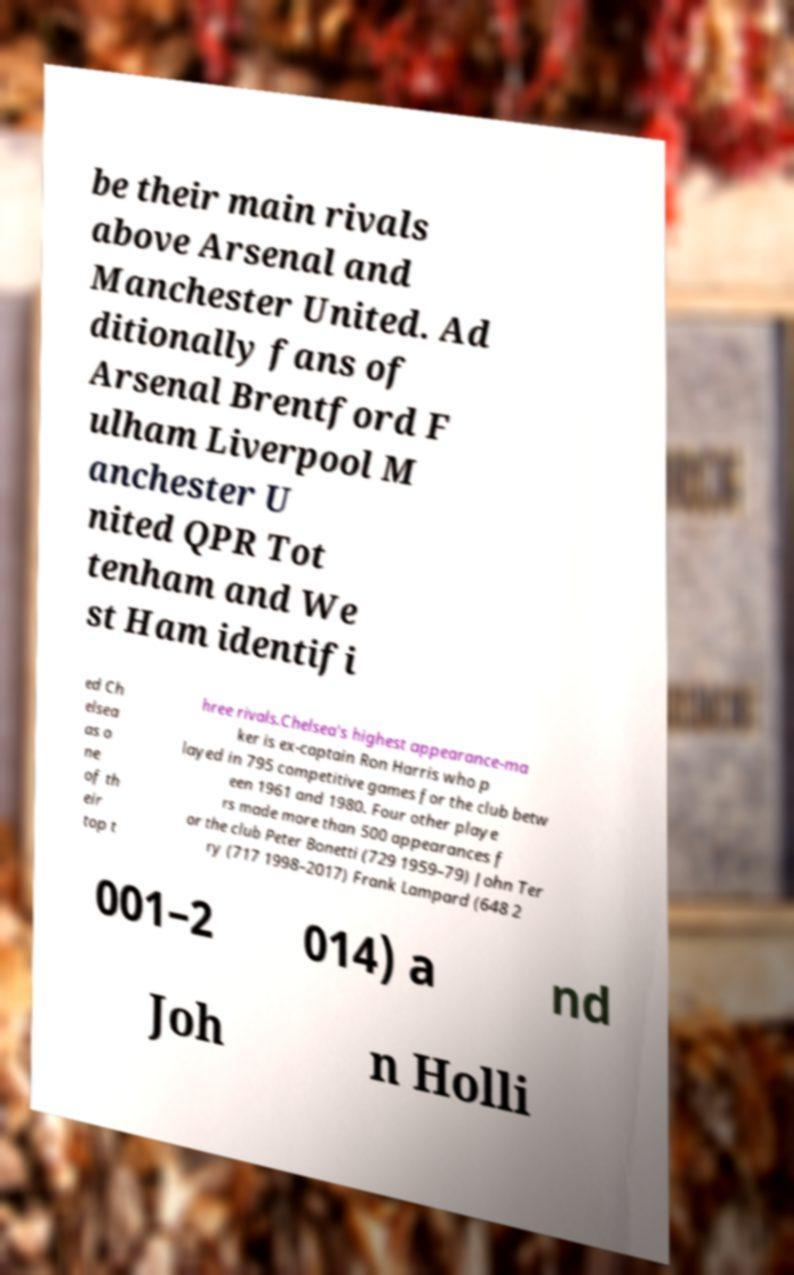Can you read and provide the text displayed in the image?This photo seems to have some interesting text. Can you extract and type it out for me? be their main rivals above Arsenal and Manchester United. Ad ditionally fans of Arsenal Brentford F ulham Liverpool M anchester U nited QPR Tot tenham and We st Ham identifi ed Ch elsea as o ne of th eir top t hree rivals.Chelsea's highest appearance-ma ker is ex-captain Ron Harris who p layed in 795 competitive games for the club betw een 1961 and 1980. Four other playe rs made more than 500 appearances f or the club Peter Bonetti (729 1959–79) John Ter ry (717 1998–2017) Frank Lampard (648 2 001–2 014) a nd Joh n Holli 